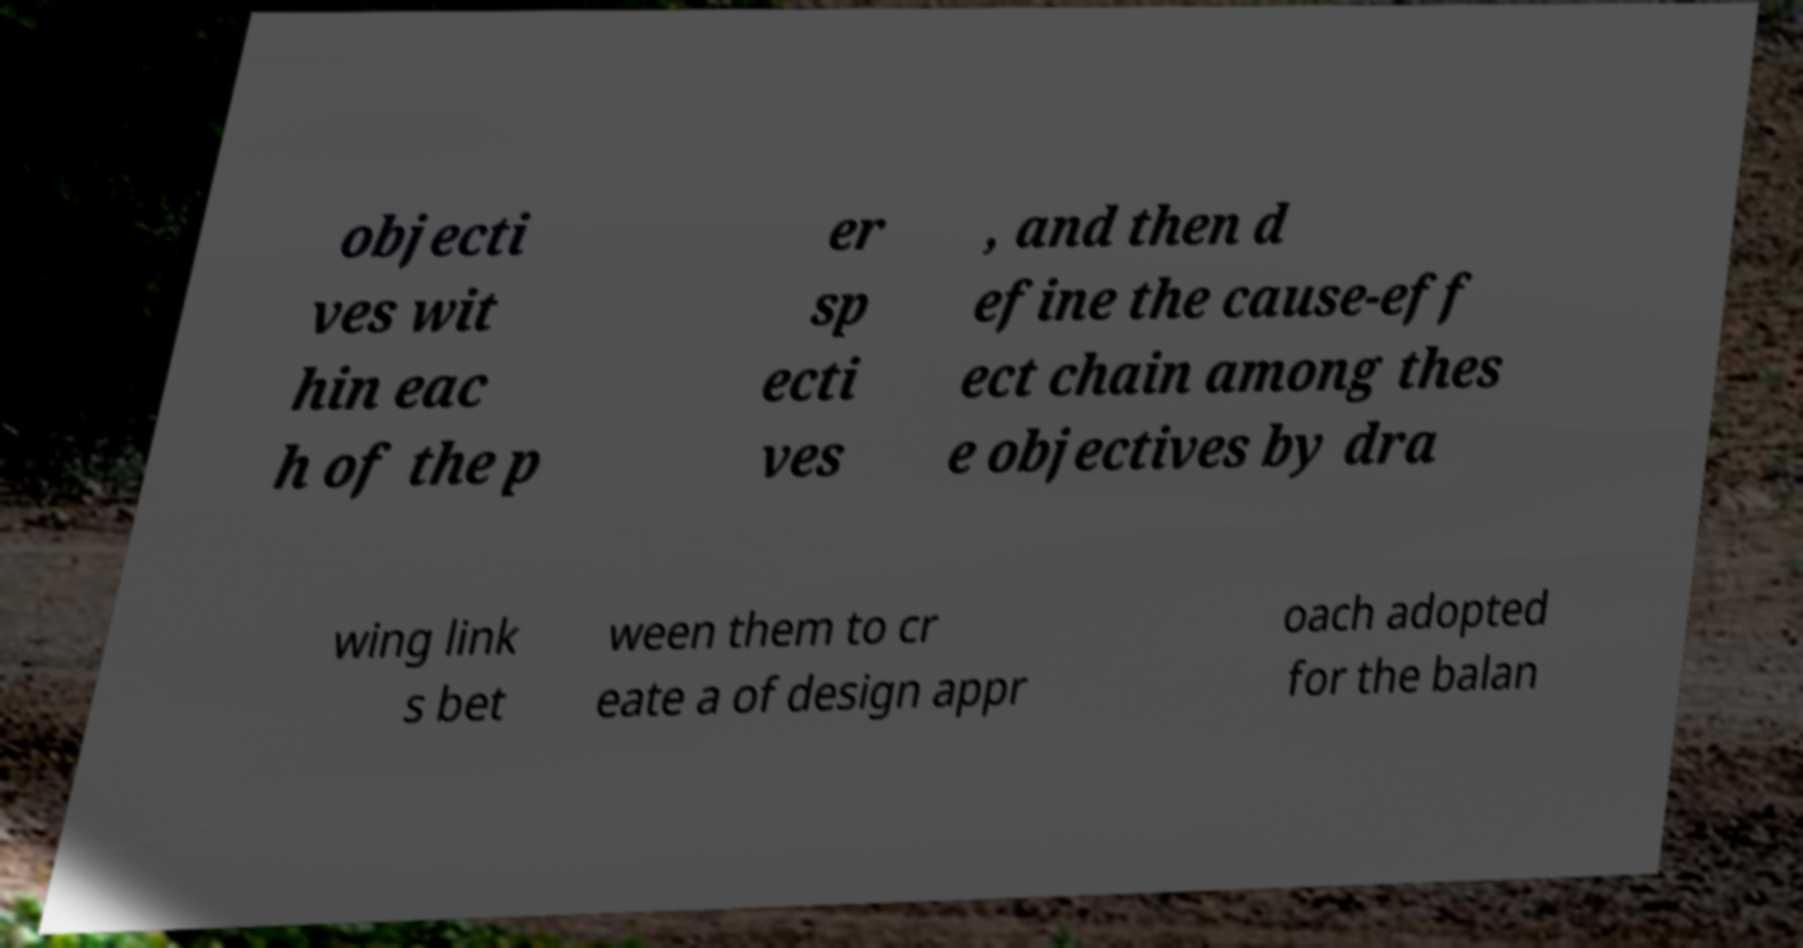Could you assist in decoding the text presented in this image and type it out clearly? objecti ves wit hin eac h of the p er sp ecti ves , and then d efine the cause-eff ect chain among thes e objectives by dra wing link s bet ween them to cr eate a of design appr oach adopted for the balan 